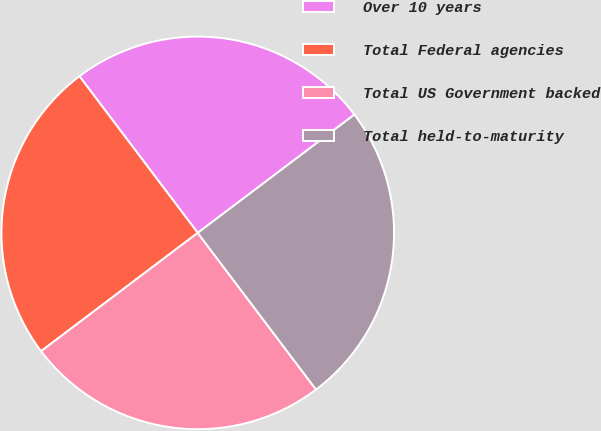Convert chart to OTSL. <chart><loc_0><loc_0><loc_500><loc_500><pie_chart><fcel>Over 10 years<fcel>Total Federal agencies<fcel>Total US Government backed<fcel>Total held-to-maturity<nl><fcel>25.0%<fcel>25.0%<fcel>25.0%<fcel>25.0%<nl></chart> 